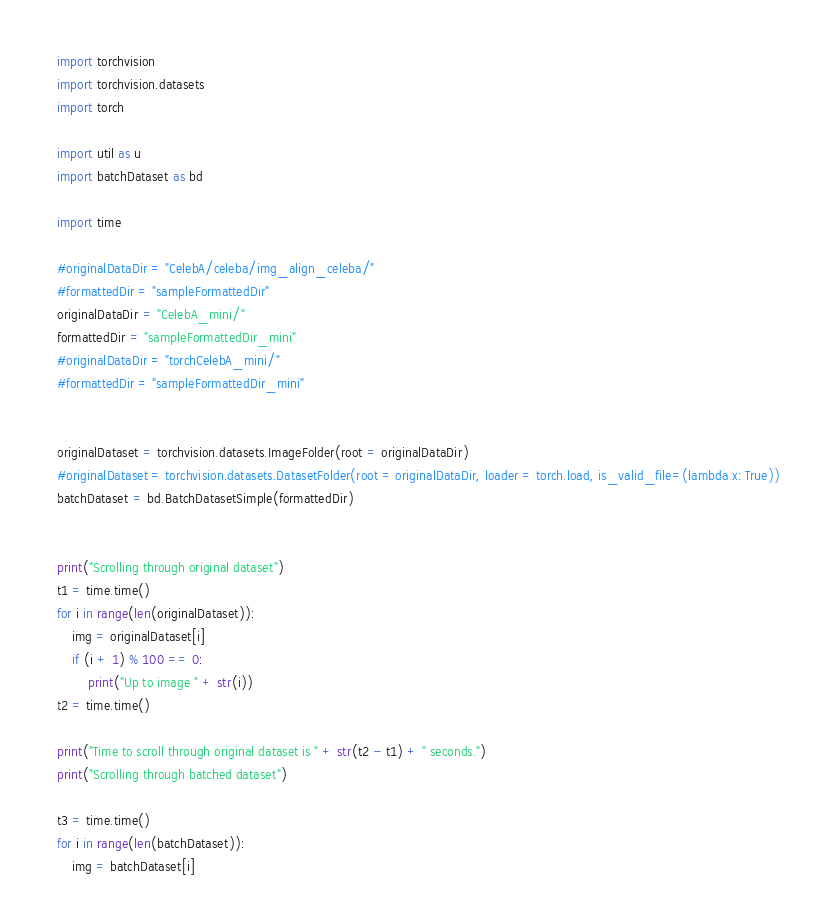Convert code to text. <code><loc_0><loc_0><loc_500><loc_500><_Python_>import torchvision
import torchvision.datasets
import torch

import util as u
import batchDataset as bd

import time

#originalDataDir = "CelebA/celeba/img_align_celeba/"
#formattedDir = "sampleFormattedDir"
originalDataDir = "CelebA_mini/"
formattedDir = "sampleFormattedDir_mini"
#originalDataDir = "torchCelebA_mini/"
#formattedDir = "sampleFormattedDir_mini"


originalDataset = torchvision.datasets.ImageFolder(root = originalDataDir)
#originalDataset = torchvision.datasets.DatasetFolder(root = originalDataDir, loader = torch.load, is_valid_file=(lambda x: True))
batchDataset = bd.BatchDatasetSimple(formattedDir)


print("Scrolling through original dataset")
t1 = time.time()
for i in range(len(originalDataset)):
    img = originalDataset[i]
    if (i + 1) % 100 == 0:
        print("Up to image " + str(i))
t2 = time.time()

print("Time to scroll through original dataset is " + str(t2 - t1) + " seconds.")
print("Scrolling through batched dataset")

t3 = time.time()
for i in range(len(batchDataset)):
    img = batchDataset[i]</code> 